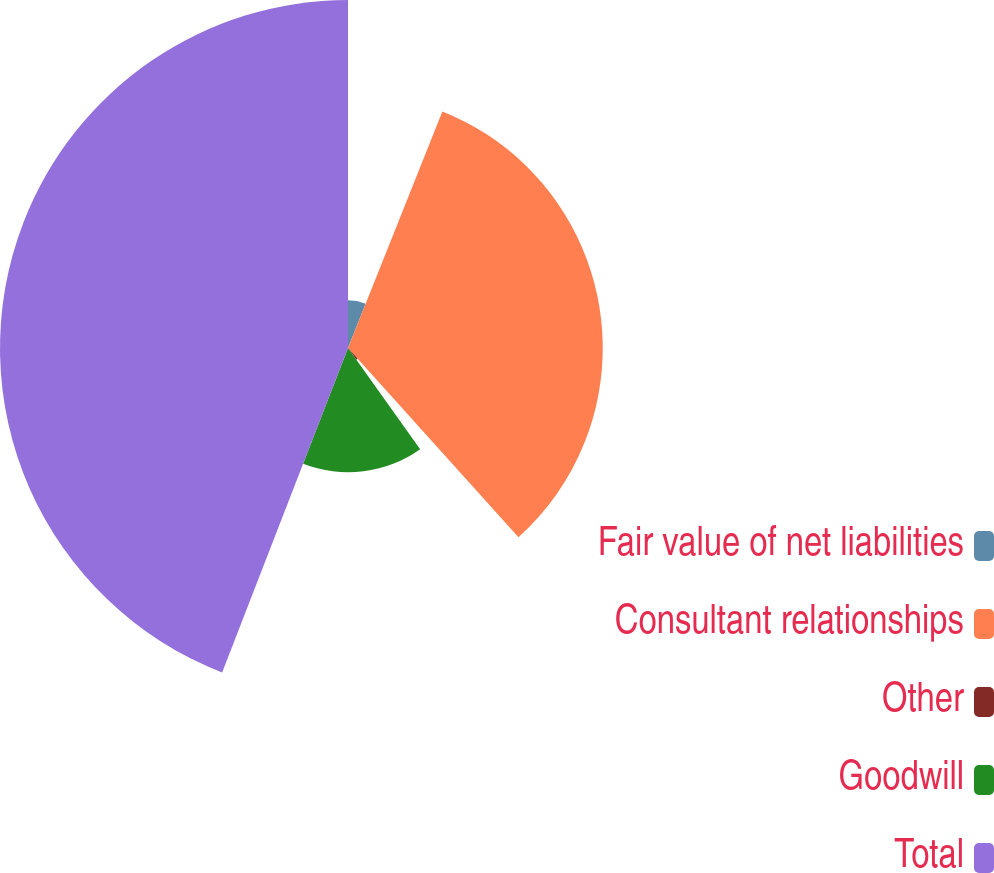Convert chart. <chart><loc_0><loc_0><loc_500><loc_500><pie_chart><fcel>Fair value of net liabilities<fcel>Consultant relationships<fcel>Other<fcel>Goodwill<fcel>Total<nl><fcel>6.04%<fcel>32.29%<fcel>1.81%<fcel>15.75%<fcel>44.11%<nl></chart> 